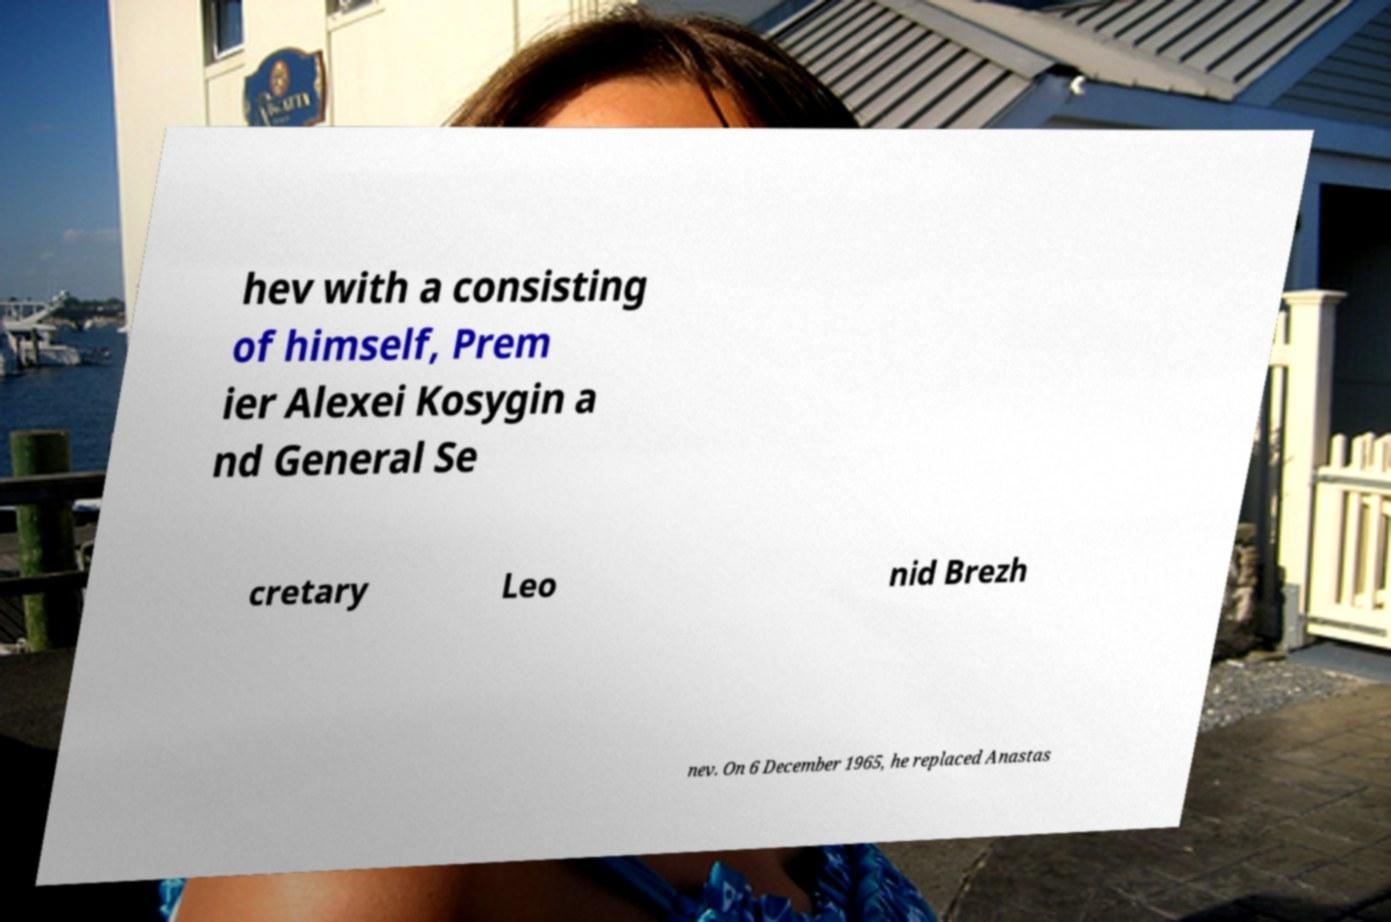Can you accurately transcribe the text from the provided image for me? hev with a consisting of himself, Prem ier Alexei Kosygin a nd General Se cretary Leo nid Brezh nev. On 6 December 1965, he replaced Anastas 